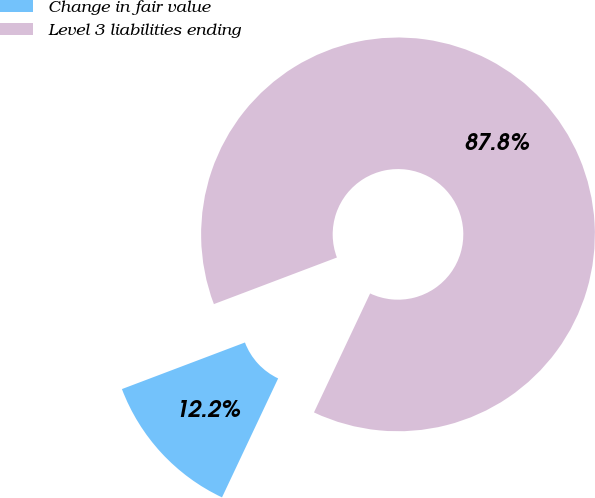Convert chart. <chart><loc_0><loc_0><loc_500><loc_500><pie_chart><fcel>Change in fair value<fcel>Level 3 liabilities ending<nl><fcel>12.22%<fcel>87.78%<nl></chart> 